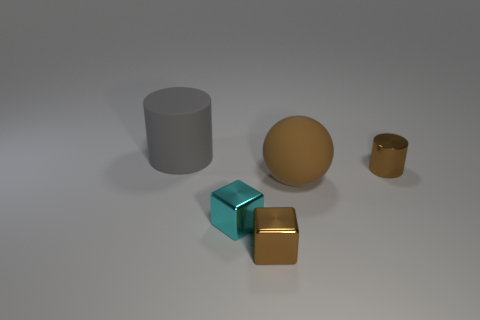What is the size of the metallic cube that is the same color as the metal cylinder?
Ensure brevity in your answer.  Small. Does the big matte thing on the left side of the brown shiny block have the same shape as the small brown thing behind the brown rubber sphere?
Provide a succinct answer. Yes. What number of brown metallic objects are right of the cyan metal thing?
Provide a short and direct response. 2. What is the color of the small block behind the brown shiny cube?
Provide a succinct answer. Cyan. What color is the other object that is the same shape as the cyan thing?
Offer a very short reply. Brown. Is there any other thing of the same color as the small metal cylinder?
Give a very brief answer. Yes. Is the number of brown blocks greater than the number of cylinders?
Provide a succinct answer. No. Do the brown block and the large gray cylinder have the same material?
Provide a short and direct response. No. How many brown objects have the same material as the large ball?
Your answer should be very brief. 0. There is a rubber cylinder; is its size the same as the brown metal thing that is on the left side of the shiny cylinder?
Make the answer very short. No. 